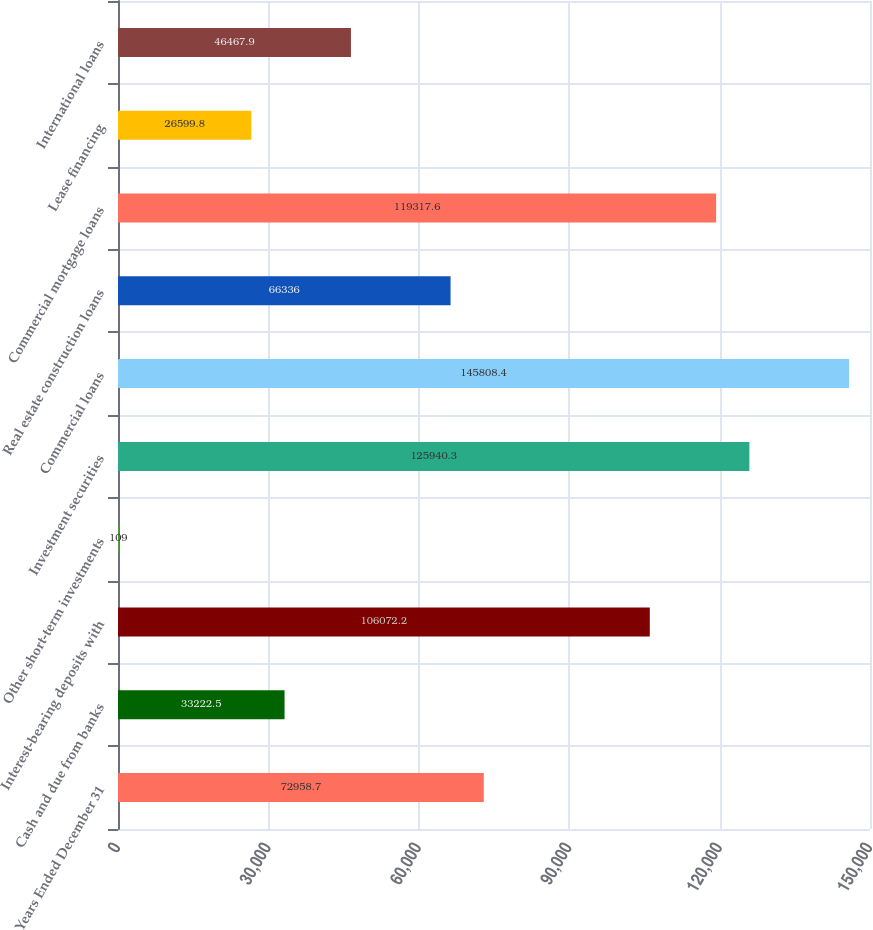<chart> <loc_0><loc_0><loc_500><loc_500><bar_chart><fcel>Years Ended December 31<fcel>Cash and due from banks<fcel>Interest-bearing deposits with<fcel>Other short-term investments<fcel>Investment securities<fcel>Commercial loans<fcel>Real estate construction loans<fcel>Commercial mortgage loans<fcel>Lease financing<fcel>International loans<nl><fcel>72958.7<fcel>33222.5<fcel>106072<fcel>109<fcel>125940<fcel>145808<fcel>66336<fcel>119318<fcel>26599.8<fcel>46467.9<nl></chart> 